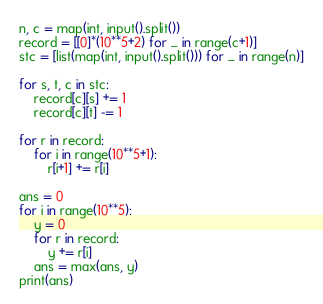Convert code to text. <code><loc_0><loc_0><loc_500><loc_500><_Python_>n, c = map(int, input().split())
record = [[0]*(10**5+2) for _ in range(c+1)]
stc = [list(map(int, input().split())) for _ in range(n)]

for s, t, c in stc:
    record[c][s] += 1
    record[c][t] -= 1

for r in record:
    for i in range(10**5+1):
        r[i+1] += r[i]

ans = 0
for i in range(10**5):
    y = 0
    for r in record:
        y += r[i]
    ans = max(ans, y)
print(ans)</code> 